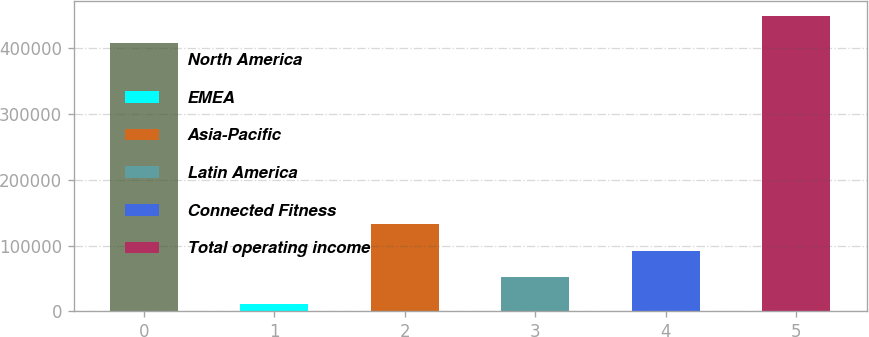Convert chart to OTSL. <chart><loc_0><loc_0><loc_500><loc_500><bar_chart><fcel>North America<fcel>EMEA<fcel>Asia-Pacific<fcel>Latin America<fcel>Connected Fitness<fcel>Total operating income<nl><fcel>408424<fcel>11420<fcel>133235<fcel>52025.1<fcel>92630.2<fcel>449029<nl></chart> 